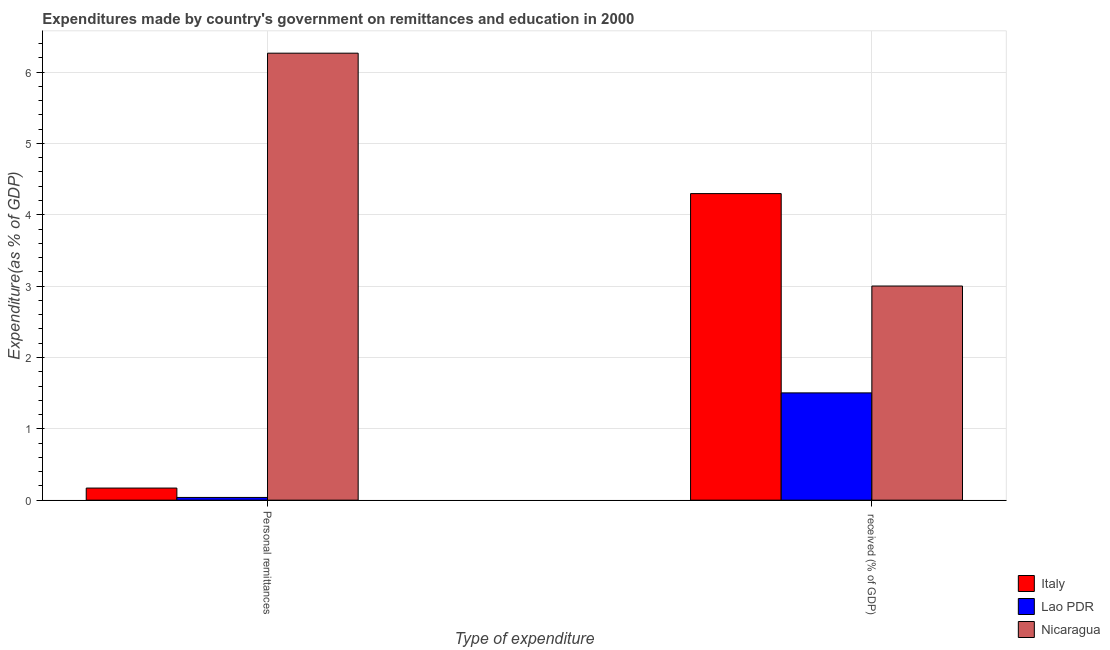How many different coloured bars are there?
Provide a short and direct response. 3. Are the number of bars on each tick of the X-axis equal?
Your answer should be very brief. Yes. What is the label of the 2nd group of bars from the left?
Your response must be concise.  received (% of GDP). What is the expenditure in personal remittances in Italy?
Make the answer very short. 0.17. Across all countries, what is the maximum expenditure in personal remittances?
Provide a succinct answer. 6.27. Across all countries, what is the minimum expenditure in education?
Your response must be concise. 1.5. In which country was the expenditure in personal remittances maximum?
Ensure brevity in your answer.  Nicaragua. In which country was the expenditure in education minimum?
Give a very brief answer. Lao PDR. What is the total expenditure in education in the graph?
Make the answer very short. 8.8. What is the difference between the expenditure in personal remittances in Lao PDR and that in Italy?
Make the answer very short. -0.13. What is the difference between the expenditure in personal remittances in Lao PDR and the expenditure in education in Nicaragua?
Your answer should be very brief. -2.96. What is the average expenditure in education per country?
Offer a terse response. 2.93. What is the difference between the expenditure in education and expenditure in personal remittances in Nicaragua?
Your answer should be compact. -3.26. In how many countries, is the expenditure in personal remittances greater than 4.6 %?
Offer a terse response. 1. What is the ratio of the expenditure in personal remittances in Lao PDR to that in Nicaragua?
Offer a very short reply. 0.01. In how many countries, is the expenditure in personal remittances greater than the average expenditure in personal remittances taken over all countries?
Provide a succinct answer. 1. How many bars are there?
Provide a short and direct response. 6. What is the difference between two consecutive major ticks on the Y-axis?
Offer a very short reply. 1. Are the values on the major ticks of Y-axis written in scientific E-notation?
Provide a succinct answer. No. Where does the legend appear in the graph?
Give a very brief answer. Bottom right. How are the legend labels stacked?
Make the answer very short. Vertical. What is the title of the graph?
Ensure brevity in your answer.  Expenditures made by country's government on remittances and education in 2000. Does "Grenada" appear as one of the legend labels in the graph?
Provide a succinct answer. No. What is the label or title of the X-axis?
Your response must be concise. Type of expenditure. What is the label or title of the Y-axis?
Offer a very short reply. Expenditure(as % of GDP). What is the Expenditure(as % of GDP) of Italy in Personal remittances?
Give a very brief answer. 0.17. What is the Expenditure(as % of GDP) in Lao PDR in Personal remittances?
Offer a very short reply. 0.04. What is the Expenditure(as % of GDP) of Nicaragua in Personal remittances?
Make the answer very short. 6.27. What is the Expenditure(as % of GDP) in Italy in  received (% of GDP)?
Provide a succinct answer. 4.3. What is the Expenditure(as % of GDP) of Lao PDR in  received (% of GDP)?
Give a very brief answer. 1.5. What is the Expenditure(as % of GDP) of Nicaragua in  received (% of GDP)?
Make the answer very short. 3. Across all Type of expenditure, what is the maximum Expenditure(as % of GDP) in Italy?
Make the answer very short. 4.3. Across all Type of expenditure, what is the maximum Expenditure(as % of GDP) of Lao PDR?
Make the answer very short. 1.5. Across all Type of expenditure, what is the maximum Expenditure(as % of GDP) in Nicaragua?
Your answer should be compact. 6.27. Across all Type of expenditure, what is the minimum Expenditure(as % of GDP) in Italy?
Keep it short and to the point. 0.17. Across all Type of expenditure, what is the minimum Expenditure(as % of GDP) of Lao PDR?
Provide a short and direct response. 0.04. Across all Type of expenditure, what is the minimum Expenditure(as % of GDP) in Nicaragua?
Offer a terse response. 3. What is the total Expenditure(as % of GDP) in Italy in the graph?
Ensure brevity in your answer.  4.47. What is the total Expenditure(as % of GDP) of Lao PDR in the graph?
Provide a short and direct response. 1.54. What is the total Expenditure(as % of GDP) of Nicaragua in the graph?
Offer a terse response. 9.27. What is the difference between the Expenditure(as % of GDP) of Italy in Personal remittances and that in  received (% of GDP)?
Ensure brevity in your answer.  -4.13. What is the difference between the Expenditure(as % of GDP) of Lao PDR in Personal remittances and that in  received (% of GDP)?
Offer a very short reply. -1.47. What is the difference between the Expenditure(as % of GDP) of Nicaragua in Personal remittances and that in  received (% of GDP)?
Your answer should be very brief. 3.26. What is the difference between the Expenditure(as % of GDP) of Italy in Personal remittances and the Expenditure(as % of GDP) of Lao PDR in  received (% of GDP)?
Your answer should be compact. -1.33. What is the difference between the Expenditure(as % of GDP) of Italy in Personal remittances and the Expenditure(as % of GDP) of Nicaragua in  received (% of GDP)?
Make the answer very short. -2.83. What is the difference between the Expenditure(as % of GDP) in Lao PDR in Personal remittances and the Expenditure(as % of GDP) in Nicaragua in  received (% of GDP)?
Make the answer very short. -2.96. What is the average Expenditure(as % of GDP) in Italy per Type of expenditure?
Your response must be concise. 2.23. What is the average Expenditure(as % of GDP) in Lao PDR per Type of expenditure?
Make the answer very short. 0.77. What is the average Expenditure(as % of GDP) of Nicaragua per Type of expenditure?
Keep it short and to the point. 4.63. What is the difference between the Expenditure(as % of GDP) in Italy and Expenditure(as % of GDP) in Lao PDR in Personal remittances?
Provide a short and direct response. 0.13. What is the difference between the Expenditure(as % of GDP) of Italy and Expenditure(as % of GDP) of Nicaragua in Personal remittances?
Your answer should be compact. -6.1. What is the difference between the Expenditure(as % of GDP) of Lao PDR and Expenditure(as % of GDP) of Nicaragua in Personal remittances?
Your answer should be compact. -6.23. What is the difference between the Expenditure(as % of GDP) in Italy and Expenditure(as % of GDP) in Lao PDR in  received (% of GDP)?
Offer a terse response. 2.79. What is the difference between the Expenditure(as % of GDP) of Italy and Expenditure(as % of GDP) of Nicaragua in  received (% of GDP)?
Offer a very short reply. 1.3. What is the difference between the Expenditure(as % of GDP) of Lao PDR and Expenditure(as % of GDP) of Nicaragua in  received (% of GDP)?
Keep it short and to the point. -1.5. What is the ratio of the Expenditure(as % of GDP) of Italy in Personal remittances to that in  received (% of GDP)?
Keep it short and to the point. 0.04. What is the ratio of the Expenditure(as % of GDP) of Lao PDR in Personal remittances to that in  received (% of GDP)?
Provide a succinct answer. 0.03. What is the ratio of the Expenditure(as % of GDP) in Nicaragua in Personal remittances to that in  received (% of GDP)?
Provide a succinct answer. 2.09. What is the difference between the highest and the second highest Expenditure(as % of GDP) in Italy?
Provide a short and direct response. 4.13. What is the difference between the highest and the second highest Expenditure(as % of GDP) of Lao PDR?
Give a very brief answer. 1.47. What is the difference between the highest and the second highest Expenditure(as % of GDP) in Nicaragua?
Offer a very short reply. 3.26. What is the difference between the highest and the lowest Expenditure(as % of GDP) in Italy?
Offer a very short reply. 4.13. What is the difference between the highest and the lowest Expenditure(as % of GDP) of Lao PDR?
Your response must be concise. 1.47. What is the difference between the highest and the lowest Expenditure(as % of GDP) of Nicaragua?
Your response must be concise. 3.26. 